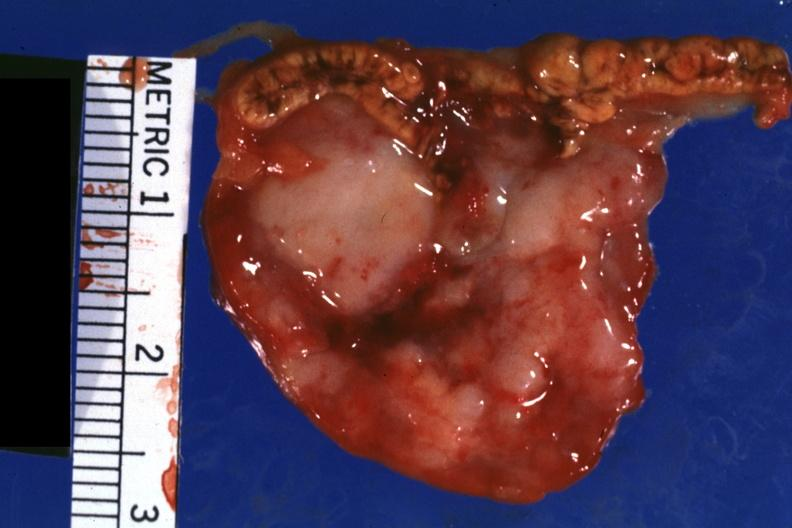s carcinomatosis endometrium primary present?
Answer the question using a single word or phrase. No 